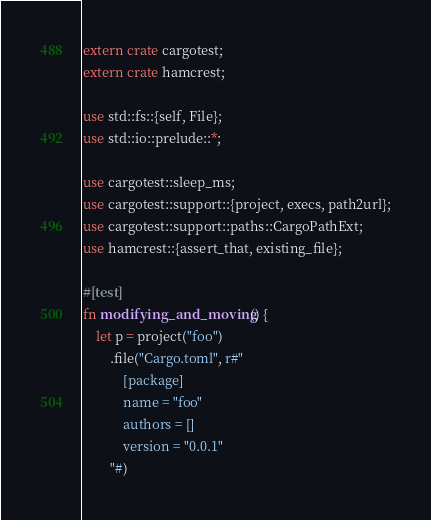Convert code to text. <code><loc_0><loc_0><loc_500><loc_500><_Rust_>extern crate cargotest;
extern crate hamcrest;

use std::fs::{self, File};
use std::io::prelude::*;

use cargotest::sleep_ms;
use cargotest::support::{project, execs, path2url};
use cargotest::support::paths::CargoPathExt;
use hamcrest::{assert_that, existing_file};

#[test]
fn modifying_and_moving() {
    let p = project("foo")
        .file("Cargo.toml", r#"
            [package]
            name = "foo"
            authors = []
            version = "0.0.1"
        "#)</code> 